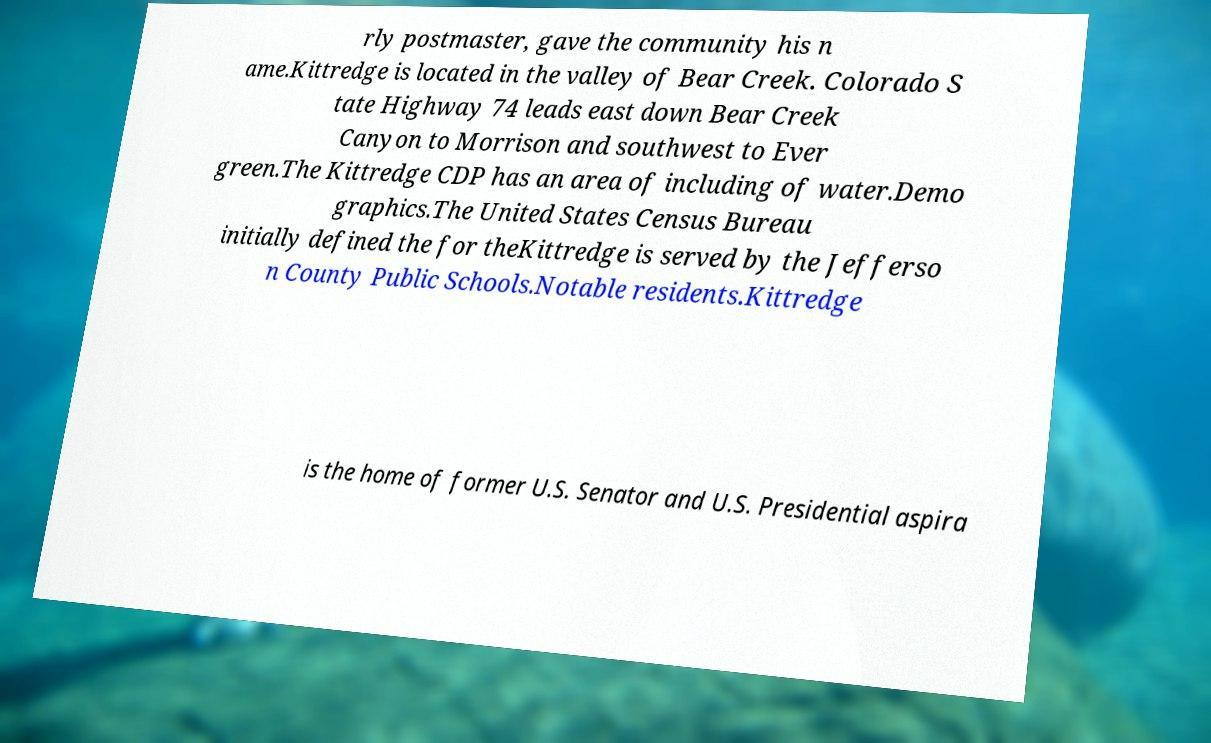Could you extract and type out the text from this image? rly postmaster, gave the community his n ame.Kittredge is located in the valley of Bear Creek. Colorado S tate Highway 74 leads east down Bear Creek Canyon to Morrison and southwest to Ever green.The Kittredge CDP has an area of including of water.Demo graphics.The United States Census Bureau initially defined the for theKittredge is served by the Jefferso n County Public Schools.Notable residents.Kittredge is the home of former U.S. Senator and U.S. Presidential aspira 